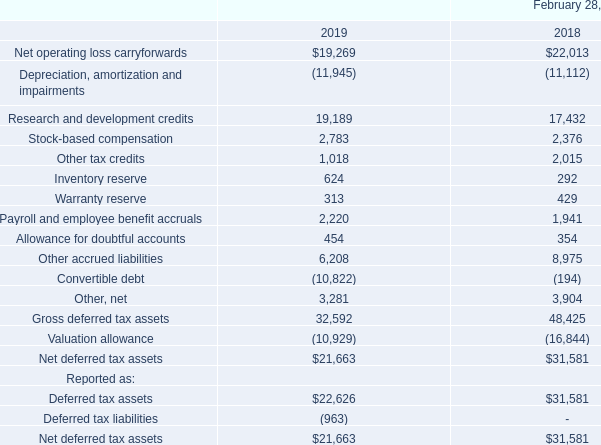The components of net deferred income tax assets for income tax purposes are as follows (in thousands):
The net deferred tax assets as of February 28, 2018 in the above table include the deferred tax assets of our Italian and Canadian subsidiaries amounting to $7.4 million and $7.6 million, respectively, which were disclosed narratively in the fiscal 2018 Form 10-K. The deferred tax assets primarily relate to net operating losses (NOL’s) and research and development expenditure pool carryforwards. We had provided a 100% valuation allowance against these deferred tax assets at February 28, 2018, as it was more likely than not that the deferred tax assets would not be realized.
As of February 28, 2019 and 2018, we maintained a valuation allowance with respect to certain of our deferred tax assets relating primarily to NOL’s in certain non-U.S. jurisdictions and certain state tax credits that we believe are not likely to be realized. During fiscal 2019, we decreased the valuation allowance against our deferred tax assets by approximately $5.9 million, as it is more likely than not that these deferred tax assets would be realized based upon the assessment of positive and negative evidence. This reduction in our valuation allowance is primarily attributable to a release of valuation allowance against foreign deferred tax assets, partially offset by an increase in valuation allowances for state tax credits.
At February 28, 2019, we had net operating loss carryforwards of approximately $30.1 million, $60.8 million and $44.7 million for federal, state and foreign purposes, respectively, expiring at various dates through fiscal 2039. Approximately $18.3 million of foreign net operating loss carryforwards do not expire. The federal net operating loss carryforwards are subject to various limitations under Section 382 of the Internal Revenue Code. If substantial changes in our ownership were to occur, there may be certain annual limitations on the amount of the NOL carryforwards that can be utilized
As of February 28, 2019, we had R&D tax credit carryforwards of $9.1 million and $8.9 million for federal and state income tax purposes, respectively. The federal R&D tax credits expire at various dates through 2039. A substantial portion of the state R&D tax credits have no expiration date.
We adopted the updated guidance on stock based compensation and we have tax deductions on exercised stock options and vested restricted stock awards that exceed stock compensation expense amounts recognized for financial reporting purposes. The gross excess tax deductions were $2.9 million, $2.6 and $0 in fiscal years 2019, 2018 and 2017, respectively. Under the new guidance, all excess tax benefits and tax deficiencies are recognized in the income statement as they occur.
We follow ASC Topic 740, “Income Taxes,” which clarifies the accounting for income taxes by prescribing a minimum recognition threshold that a tax position is required to meet before being recognized in the financial statements. Management determined based on our evaluation of our income tax positions that we have uncertain tax benefit of $3.2 million, $1.0 million and $1.0 million on at February 28, 2019, 2018 and 2017, respectively, for which we have not yet recognized an income tax benefit for financial reporting purposes.
At February 28, 2019, we increased the uncertain tax benefits related to certain foreign net operating loss carryforwards. Such deferred tax assets were previously offset by a valuation allowance so that the increase in the unrecognized tax benefit coupled with the reduction of the valuation allowance on such net operating losses did not result in an income tax expense during the current fiscal year. If total uncertain tax benefits were realized in a future period, it would result in a tax benefit of $3.2 million. As of February 28, 2019, our liabilities for uncertain tax benefits were netted against our deferred tax assets on our consolidated balance sheet. It is reasonably possible the amount of unrecognized tax benefits could be reduced within the next 12 months by at least $0.6 million.
We recognize interest and/or penalties related to uncertain tax positions in income tax expense. No amounts of interest and/or penalties have been accrued as of February 28, 2019.
What does the deferred tax assets primarily relate to? Net operating losses (nol’s) and research and development expenditure pool carryforwards. What was the Inventory Reserve in 2019?
Answer scale should be: thousand. 624. What was the Warranty Reserve in 2019?
Answer scale should be: thousand. 313. What was the percentage change in Inventory Reserve between 2018 to 2019?
Answer scale should be: percent. (624-292)/292
Answer: 113.7. What was the percentage change in Allowance for doubtful accounts between 2018 to 2019?
Answer scale should be: percent. (454-354)/354
Answer: 28.25. How much do the top 3 components add up to?
Answer scale should be: thousand. (19,269+19,189+6,208)
Answer: 44666. 